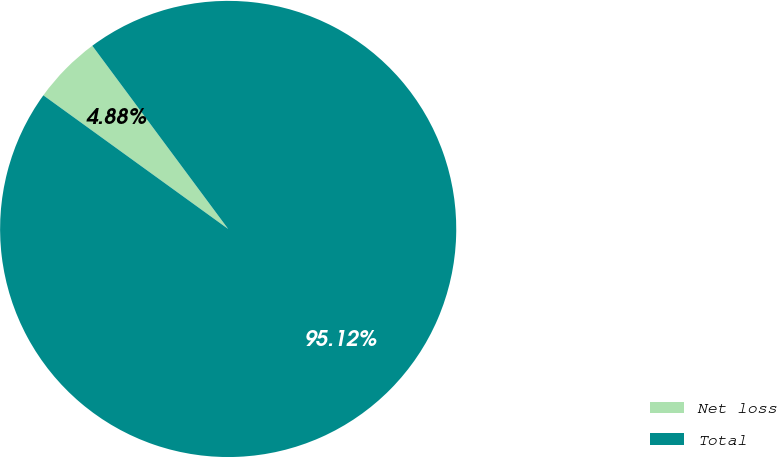<chart> <loc_0><loc_0><loc_500><loc_500><pie_chart><fcel>Net loss<fcel>Total<nl><fcel>4.88%<fcel>95.12%<nl></chart> 